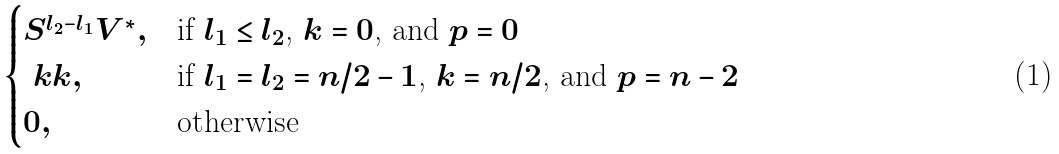<formula> <loc_0><loc_0><loc_500><loc_500>\begin{cases} S ^ { l _ { 2 } - l _ { 1 } } V ^ { * } , & \text {if $l_{1} \leq l_{2}$, $k = 0$, and $p = 0$} \\ \ k k , & \text {if $l_{1} = l_{2} = n/2 - 1$, $k = n/2$, and $p = n - 2$} \\ 0 , & \text {otherwise} \end{cases}</formula> 